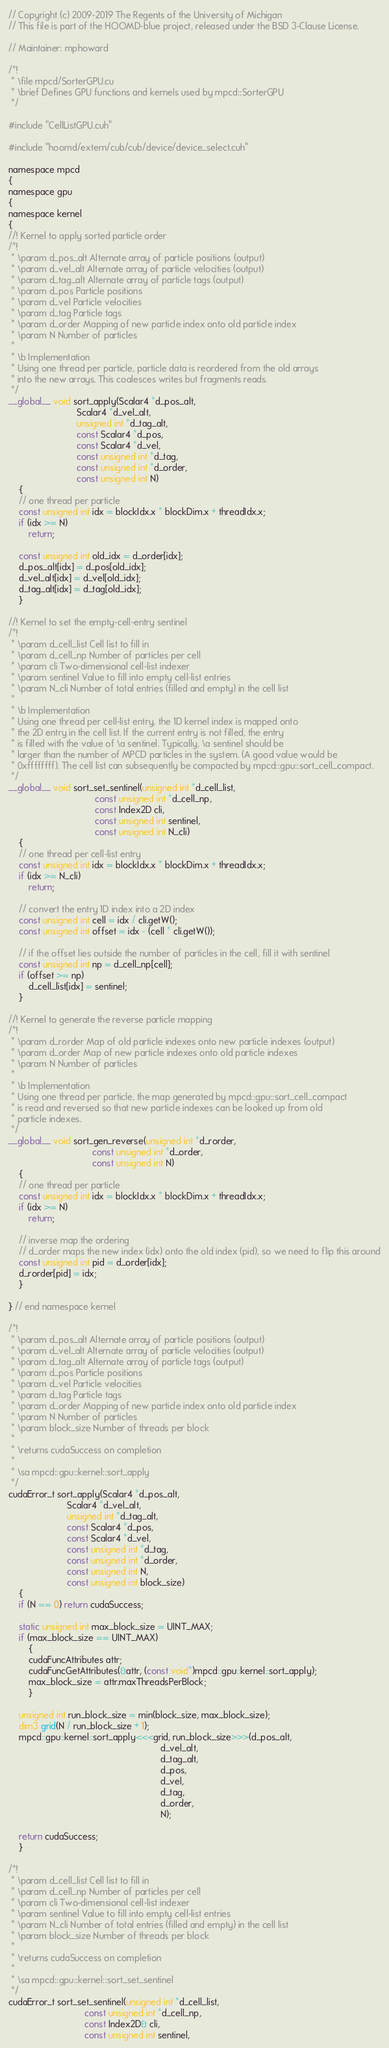Convert code to text. <code><loc_0><loc_0><loc_500><loc_500><_Cuda_>// Copyright (c) 2009-2019 The Regents of the University of Michigan
// This file is part of the HOOMD-blue project, released under the BSD 3-Clause License.

// Maintainer: mphoward

/*!
 * \file mpcd/SorterGPU.cu
 * \brief Defines GPU functions and kernels used by mpcd::SorterGPU
 */

#include "CellListGPU.cuh"

#include "hoomd/extern/cub/cub/device/device_select.cuh"

namespace mpcd
{
namespace gpu
{
namespace kernel
{
//! Kernel to apply sorted particle order
/*!
 * \param d_pos_alt Alternate array of particle positions (output)
 * \param d_vel_alt Alternate array of particle velocities (output)
 * \param d_tag_alt Alternate array of particle tags (output)
 * \param d_pos Particle positions
 * \param d_vel Particle velocities
 * \param d_tag Particle tags
 * \param d_order Mapping of new particle index onto old particle index
 * \param N Number of particles
 *
 * \b Implementation
 * Using one thread per particle, particle data is reordered from the old arrays
 * into the new arrays. This coalesces writes but fragments reads.
 */
__global__ void sort_apply(Scalar4 *d_pos_alt,
                           Scalar4 *d_vel_alt,
                           unsigned int *d_tag_alt,
                           const Scalar4 *d_pos,
                           const Scalar4 *d_vel,
                           const unsigned int *d_tag,
                           const unsigned int *d_order,
                           const unsigned int N)
    {
    // one thread per particle
    const unsigned int idx = blockIdx.x * blockDim.x + threadIdx.x;
    if (idx >= N)
        return;

    const unsigned int old_idx = d_order[idx];
    d_pos_alt[idx] = d_pos[old_idx];
    d_vel_alt[idx] = d_vel[old_idx];
    d_tag_alt[idx] = d_tag[old_idx];
    }

//! Kernel to set the empty-cell-entry sentinel
/*!
 * \param d_cell_list Cell list to fill in
 * \param d_cell_np Number of particles per cell
 * \param cli Two-dimensional cell-list indexer
 * \param sentinel Value to fill into empty cell-list entries
 * \param N_cli Number of total entries (filled and empty) in the cell list
 *
 * \b Implementation
 * Using one thread per cell-list entry, the 1D kernel index is mapped onto
 * the 2D entry in the cell list. If the current entry is not filled, the entry
 * is filled with the value of \a sentinel. Typically, \a sentinel should be
 * larger than the number of MPCD particles in the system. (A good value would be
 * 0xffffffff). The cell list can subsequently be compacted by mpcd::gpu::sort_cell_compact.
 */
__global__ void sort_set_sentinel(unsigned int *d_cell_list,
                                  const unsigned int *d_cell_np,
                                  const Index2D cli,
                                  const unsigned int sentinel,
                                  const unsigned int N_cli)
    {
    // one thread per cell-list entry
    const unsigned int idx = blockIdx.x * blockDim.x + threadIdx.x;
    if (idx >= N_cli)
        return;

    // convert the entry 1D index into a 2D index
    const unsigned int cell = idx / cli.getW();
    const unsigned int offset = idx - (cell * cli.getW());

    // if the offset lies outside the number of particles in the cell, fill it with sentinel
    const unsigned int np = d_cell_np[cell];
    if (offset >= np)
        d_cell_list[idx] = sentinel;
    }

//! Kernel to generate the reverse particle mapping
/*!
 * \param d_rorder Map of old particle indexes onto new particle indexes (output)
 * \param d_order Map of new particle indexes onto old particle indexes
 * \param N Number of particles
 *
 * \b Implementation
 * Using one thread per particle, the map generated by mpcd::gpu::sort_cell_compact
 * is read and reversed so that new particle indexes can be looked up from old
 * particle indexes.
 */
__global__ void sort_gen_reverse(unsigned int *d_rorder,
                                 const unsigned int *d_order,
                                 const unsigned int N)
    {
    // one thread per particle
    const unsigned int idx = blockIdx.x * blockDim.x + threadIdx.x;
    if (idx >= N)
        return;

    // inverse map the ordering
    // d_order maps the new index (idx) onto the old index (pid), so we need to flip this around
    const unsigned int pid = d_order[idx];
    d_rorder[pid] = idx;
    }

} // end namespace kernel

/*!
 * \param d_pos_alt Alternate array of particle positions (output)
 * \param d_vel_alt Alternate array of particle velocities (output)
 * \param d_tag_alt Alternate array of particle tags (output)
 * \param d_pos Particle positions
 * \param d_vel Particle velocities
 * \param d_tag Particle tags
 * \param d_order Mapping of new particle index onto old particle index
 * \param N Number of particles
 * \param block_size Number of threads per block
 *
 * \returns cudaSuccess on completion
 *
 * \sa mpcd::gpu::kernel::sort_apply
 */
cudaError_t sort_apply(Scalar4 *d_pos_alt,
                       Scalar4 *d_vel_alt,
                       unsigned int *d_tag_alt,
                       const Scalar4 *d_pos,
                       const Scalar4 *d_vel,
                       const unsigned int *d_tag,
                       const unsigned int *d_order,
                       const unsigned int N,
                       const unsigned int block_size)
    {
    if (N == 0) return cudaSuccess;

    static unsigned int max_block_size = UINT_MAX;
    if (max_block_size == UINT_MAX)
        {
        cudaFuncAttributes attr;
        cudaFuncGetAttributes(&attr, (const void*)mpcd::gpu::kernel::sort_apply);
        max_block_size = attr.maxThreadsPerBlock;
        }

    unsigned int run_block_size = min(block_size, max_block_size);
    dim3 grid(N / run_block_size + 1);
    mpcd::gpu::kernel::sort_apply<<<grid, run_block_size>>>(d_pos_alt,
                                                            d_vel_alt,
                                                            d_tag_alt,
                                                            d_pos,
                                                            d_vel,
                                                            d_tag,
                                                            d_order,
                                                            N);

    return cudaSuccess;
    }

/*!
 * \param d_cell_list Cell list to fill in
 * \param d_cell_np Number of particles per cell
 * \param cli Two-dimensional cell-list indexer
 * \param sentinel Value to fill into empty cell-list entries
 * \param N_cli Number of total entries (filled and empty) in the cell list
 * \param block_size Number of threads per block
 *
 * \returns cudaSuccess on completion
 *
 * \sa mpcd::gpu::kernel::sort_set_sentinel
 */
cudaError_t sort_set_sentinel(unsigned int *d_cell_list,
                              const unsigned int *d_cell_np,
                              const Index2D& cli,
                              const unsigned int sentinel,</code> 